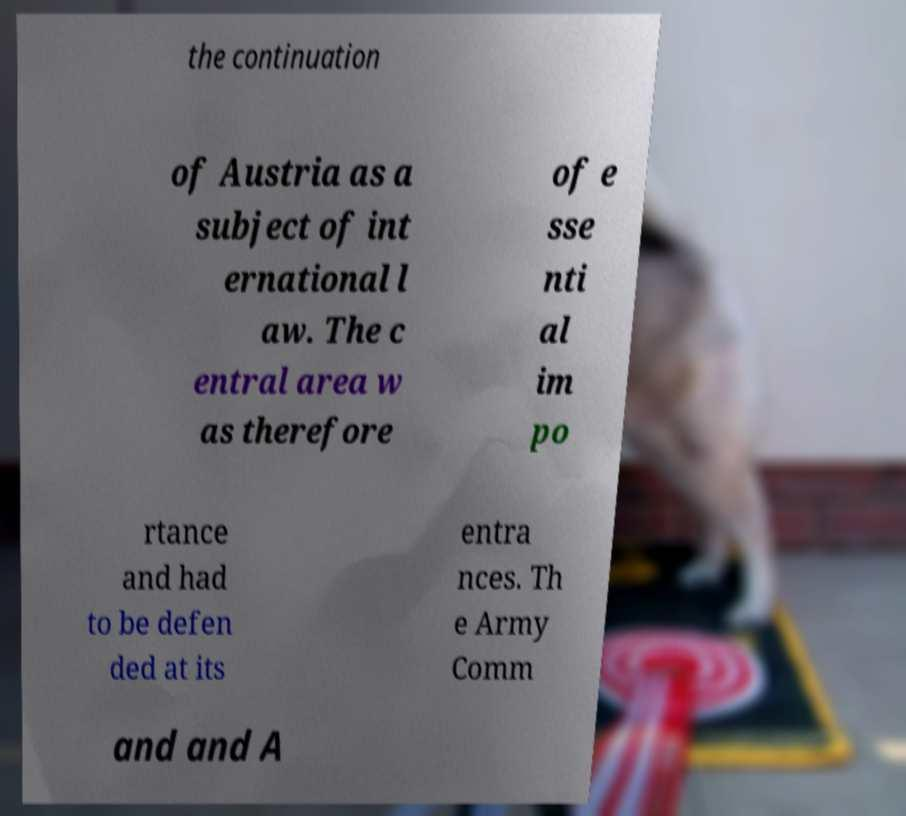Could you extract and type out the text from this image? the continuation of Austria as a subject of int ernational l aw. The c entral area w as therefore of e sse nti al im po rtance and had to be defen ded at its entra nces. Th e Army Comm and and A 